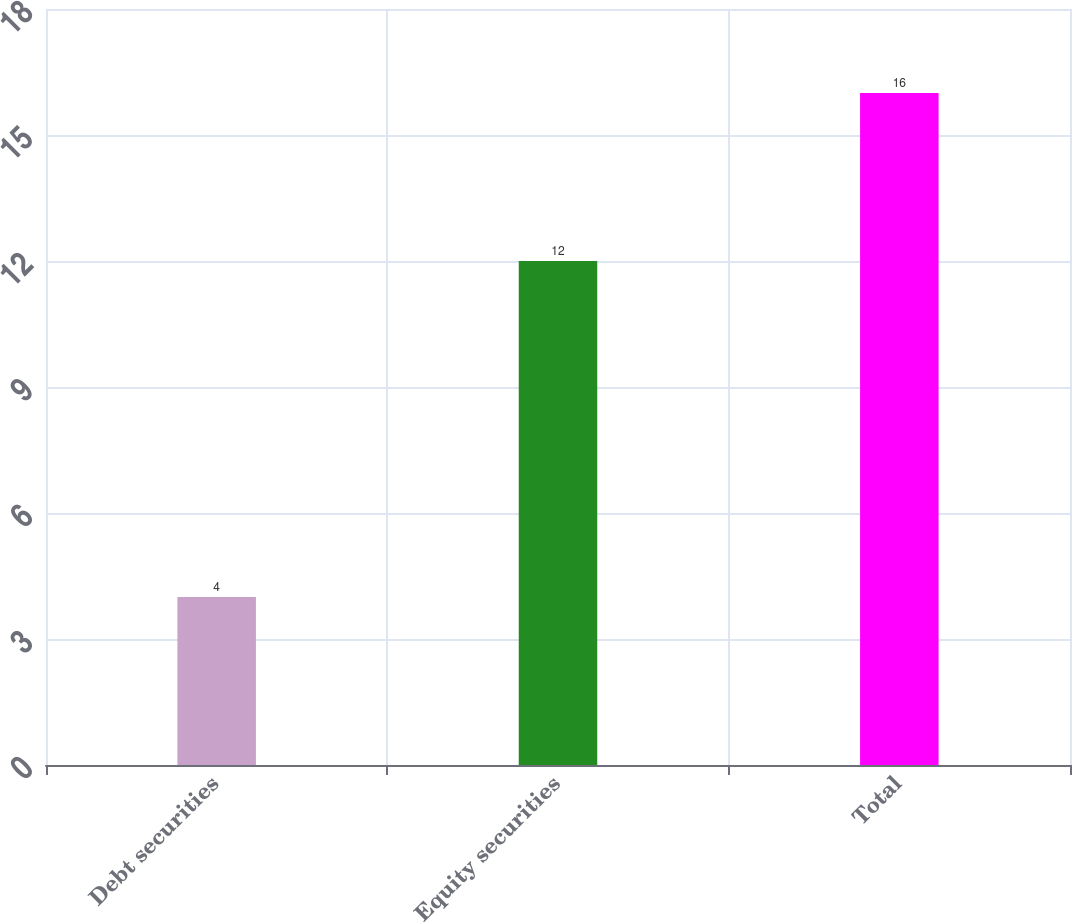<chart> <loc_0><loc_0><loc_500><loc_500><bar_chart><fcel>Debt securities<fcel>Equity securities<fcel>Total<nl><fcel>4<fcel>12<fcel>16<nl></chart> 